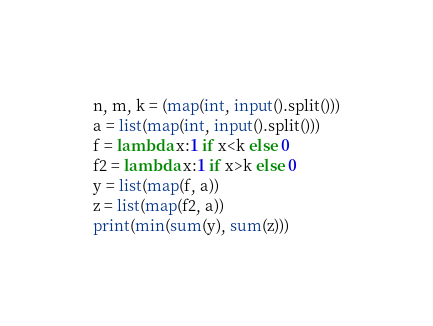Convert code to text. <code><loc_0><loc_0><loc_500><loc_500><_Python_>n, m, k = (map(int, input().split()))
a = list(map(int, input().split()))
f = lambda x:1 if x<k else 0
f2 = lambda x:1 if x>k else 0
y = list(map(f, a))
z = list(map(f2, a))
print(min(sum(y), sum(z)))
</code> 